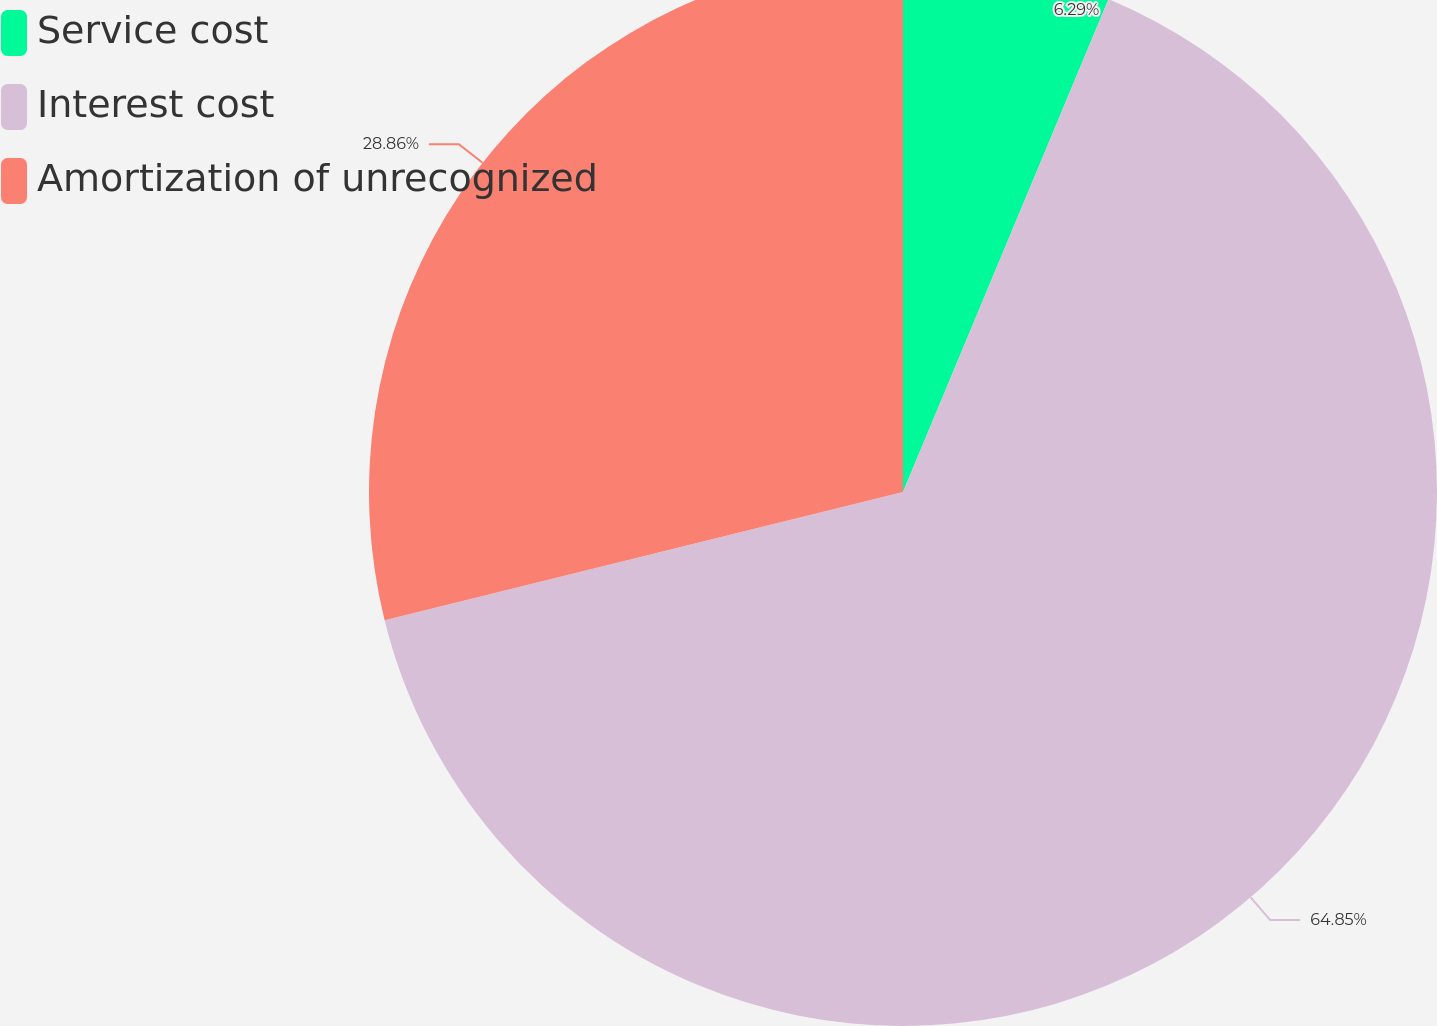<chart> <loc_0><loc_0><loc_500><loc_500><pie_chart><fcel>Service cost<fcel>Interest cost<fcel>Amortization of unrecognized<nl><fcel>6.29%<fcel>64.86%<fcel>28.86%<nl></chart> 